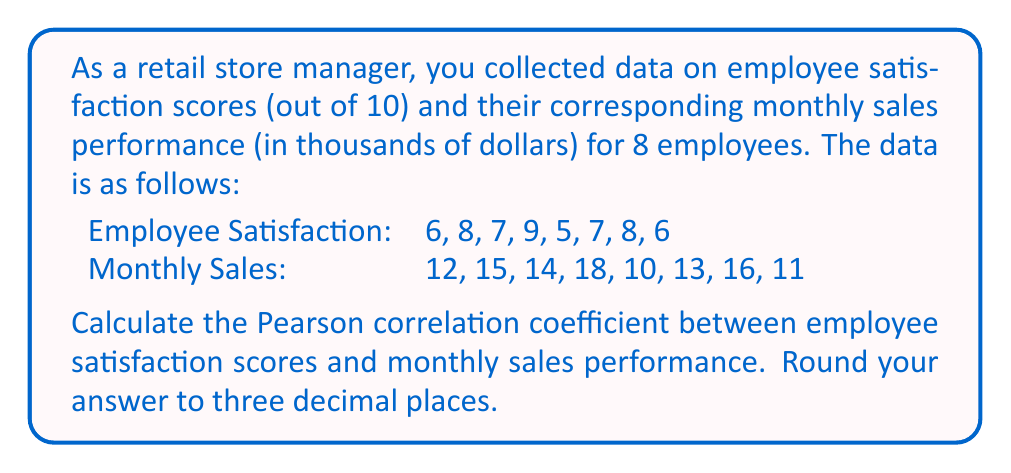Can you solve this math problem? To calculate the Pearson correlation coefficient, we'll follow these steps:

1. Calculate the means of both variables:
   $\bar{x} = \frac{6+8+7+9+5+7+8+6}{8} = 7$
   $\bar{y} = \frac{12+15+14+18+10+13+16+11}{8} = 13.625$

2. Calculate the deviations from the mean for both variables:
   $x_i - \bar{x}$: -1, 1, 0, 2, -2, 0, 1, -1
   $y_i - \bar{y}$: -1.625, 1.375, 0.375, 4.375, -3.625, -0.625, 2.375, -2.625

3. Calculate the product of the deviations:
   $(x_i - \bar{x})(y_i - \bar{y})$: 1.625, 1.375, 0, 8.75, 7.25, 0, 2.375, 2.625

4. Calculate the sum of the products of deviations:
   $\sum (x_i - \bar{x})(y_i - \bar{y}) = 24$

5. Calculate the sum of squared deviations for both variables:
   $\sum (x_i - \bar{x})^2 = 12$
   $\sum (y_i - \bar{y})^2 = 56.75$

6. Apply the Pearson correlation coefficient formula:

   $$r = \frac{\sum (x_i - \bar{x})(y_i - \bar{y})}{\sqrt{\sum (x_i - \bar{x})^2 \sum (y_i - \bar{y})^2}}$$

   $$r = \frac{24}{\sqrt{12 \times 56.75}} = \frac{24}{\sqrt{681}} = \frac{24}{26.096} = 0.919$$

7. Round to three decimal places: 0.919
Answer: 0.919 